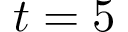<formula> <loc_0><loc_0><loc_500><loc_500>t = 5</formula> 